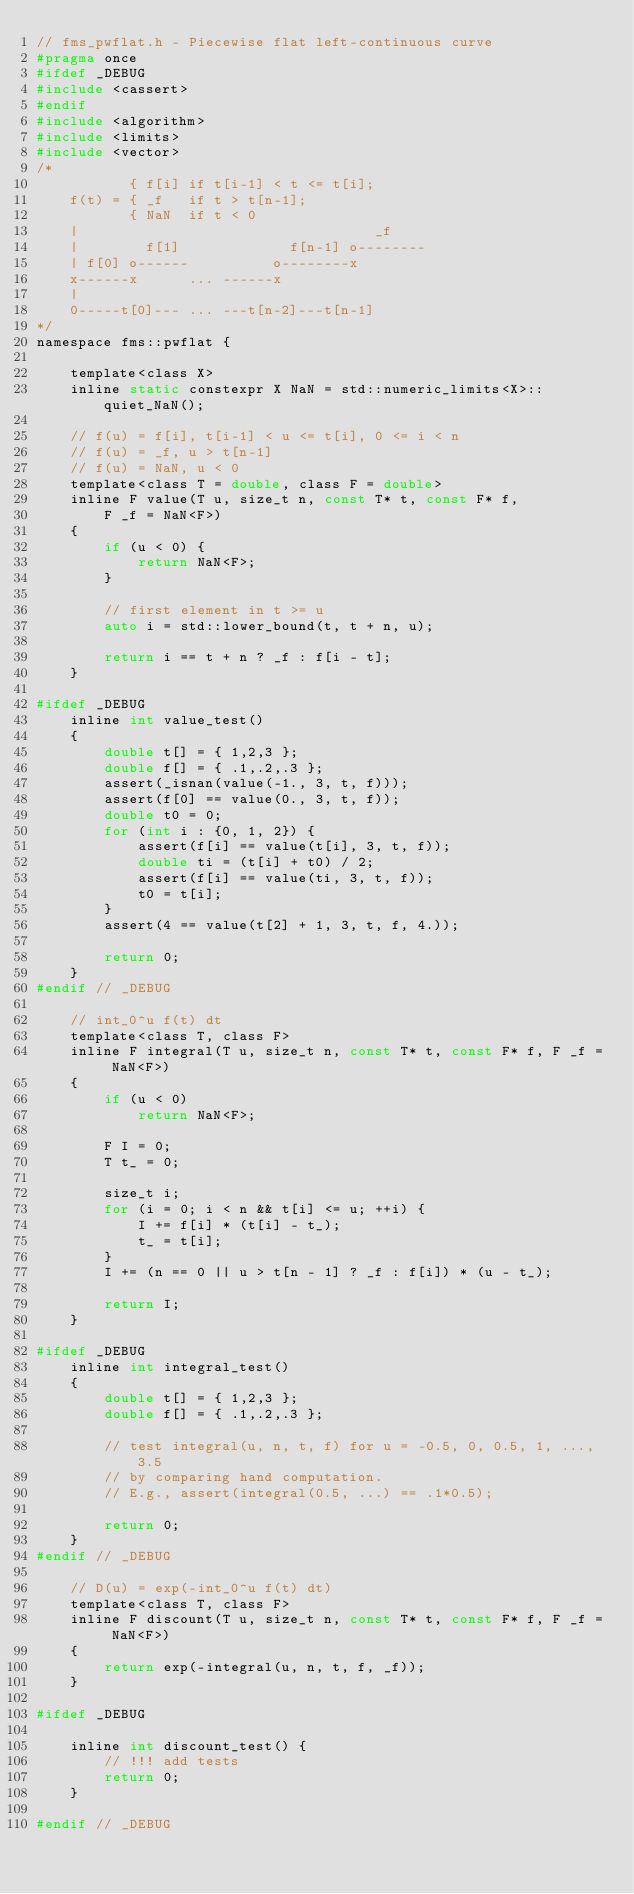<code> <loc_0><loc_0><loc_500><loc_500><_C_>// fms_pwflat.h - Piecewise flat left-continuous curve
#pragma once
#ifdef _DEBUG
#include <cassert>
#endif
#include <algorithm>
#include <limits>
#include <vector>
/*
		   { f[i] if t[i-1] < t <= t[i];
	f(t) = { _f   if t > t[n-1];
		   { NaN  if t < 0
	|                                   _f
	|        f[1]             f[n-1] o--------
	| f[0] o------          o--------x
	x------x      ... ------x
	|
	0-----t[0]--- ... ---t[n-2]---t[n-1]
*/
namespace fms::pwflat {

	template<class X>
	inline static constexpr X NaN = std::numeric_limits<X>::quiet_NaN();

	// f(u) = f[i], t[i-1] < u <= t[i], 0 <= i < n
	// f(u) = _f, u > t[n-1]
	// f(u) = NaN, u < 0
	template<class T = double, class F = double>
	inline F value(T u, size_t n, const T* t, const F* f,
		F _f = NaN<F>)
	{
		if (u < 0) {
			return NaN<F>;
		}

		// first element in t >= u
		auto i = std::lower_bound(t, t + n, u);

		return i == t + n ? _f : f[i - t];
	}

#ifdef _DEBUG
	inline int value_test()
	{
		double t[] = { 1,2,3 };
		double f[] = { .1,.2,.3 };
		assert(_isnan(value(-1., 3, t, f)));
		assert(f[0] == value(0., 3, t, f));
		double t0 = 0;
		for (int i : {0, 1, 2}) {
			assert(f[i] == value(t[i], 3, t, f));
			double ti = (t[i] + t0) / 2;
			assert(f[i] == value(ti, 3, t, f));
			t0 = t[i];
		}
		assert(4 == value(t[2] + 1, 3, t, f, 4.));

		return 0;
	}
#endif // _DEBUG

	// int_0^u f(t) dt
	template<class T, class F>
	inline F integral(T u, size_t n, const T* t, const F* f, F _f = NaN<F>)
	{
		if (u < 0)
			return NaN<F>;

		F I = 0;
		T t_ = 0;

		size_t i;
		for (i = 0; i < n && t[i] <= u; ++i) {
			I += f[i] * (t[i] - t_);
			t_ = t[i];
		}
		I += (n == 0 || u > t[n - 1] ? _f : f[i]) * (u - t_);

		return I;
	}

#ifdef _DEBUG
	inline int integral_test()
	{
		double t[] = { 1,2,3 };
		double f[] = { .1,.2,.3 };

		// test integral(u, n, t, f) for u = -0.5, 0, 0.5, 1, ..., 3.5
		// by comparing hand computation.
		// E.g., assert(integral(0.5, ...) == .1*0.5);

		return 0;
	}
#endif // _DEBUG

	// D(u) = exp(-int_0^u f(t) dt)
	template<class T, class F>
	inline F discount(T u, size_t n, const T* t, const F* f, F _f = NaN<F>)
	{
		return exp(-integral(u, n, t, f, _f));
	}

#ifdef _DEBUG

	inline int discount_test() {
		// !!! add tests
		return 0;
	}

#endif // _DEBUG
</code> 